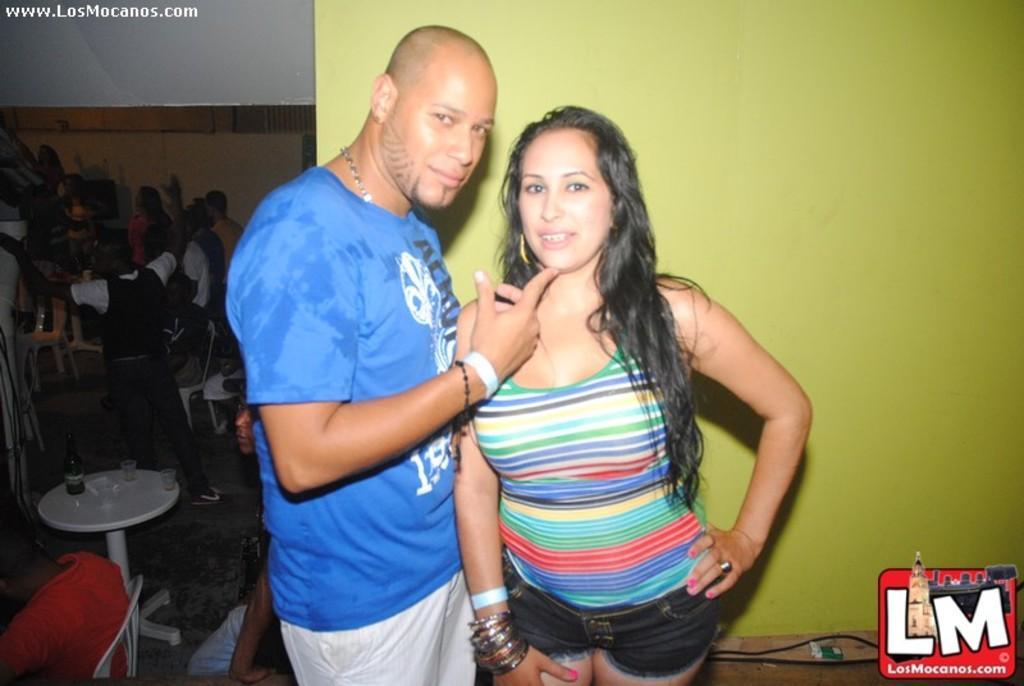In one or two sentences, can you explain what this image depicts? This image consists of two persons in the middle. One is man, another one is a woman. On the left side, there are so many people. There are tables and chairs. On the table there are glasses, tissues. 